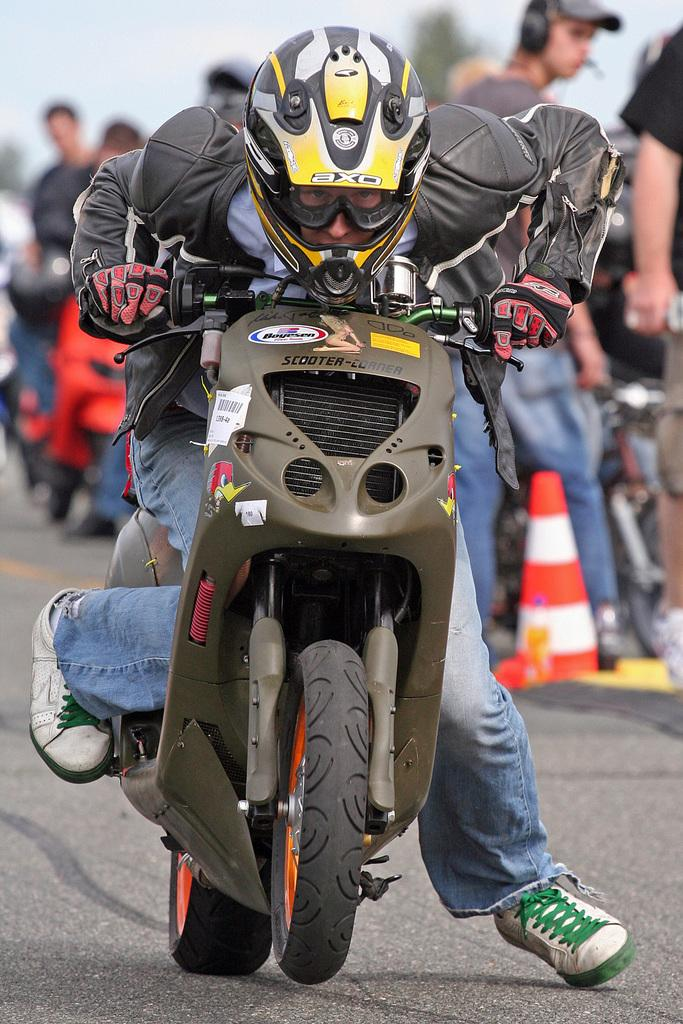What is the man in the image doing? The man is riding a bike on the road. What is happening behind the man? There is a crowd behind the man. What are some of the people in the crowd doing? Some people in the crowd are walking, and some are also riding bikes. What flavor of coil can be seen in the image? There is no coil present in the image, and therefore no flavor can be determined. 